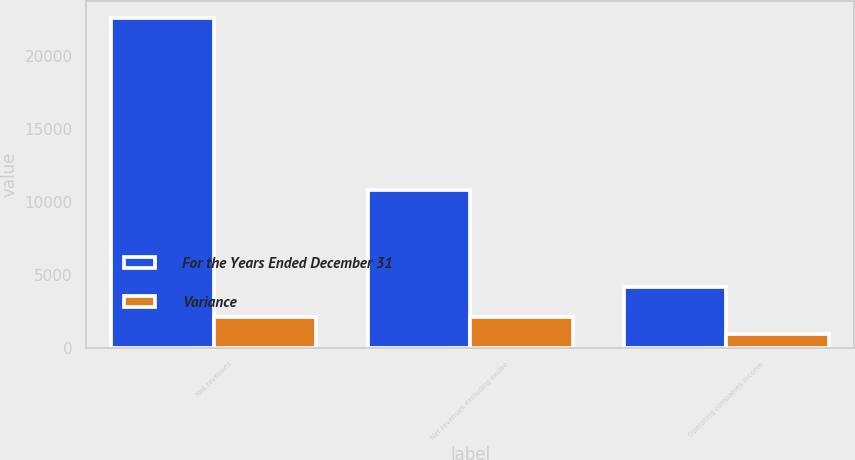Convert chart. <chart><loc_0><loc_0><loc_500><loc_500><stacked_bar_chart><ecel><fcel>Net revenues<fcel>Net revenues excluding excise<fcel>Operating companies income<nl><fcel>For the Years Ended December 31<fcel>22635<fcel>10790<fcel>4149<nl><fcel>Variance<fcel>2104<fcel>2109<fcel>953<nl></chart> 